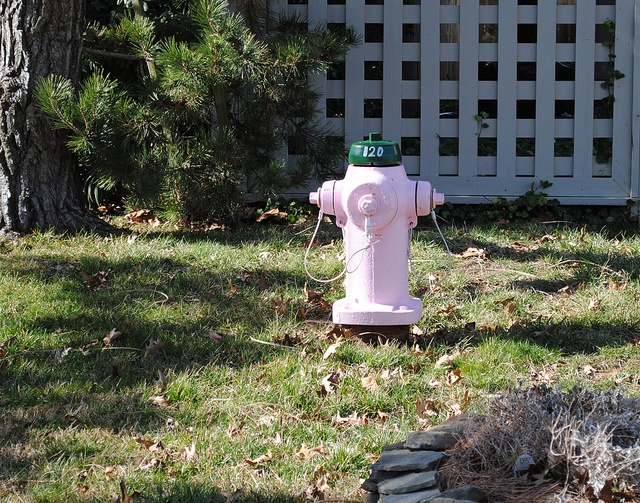Describe the objects in this image and their specific colors. I can see a fire hydrant in gray, darkgray, lavender, violet, and pink tones in this image. 